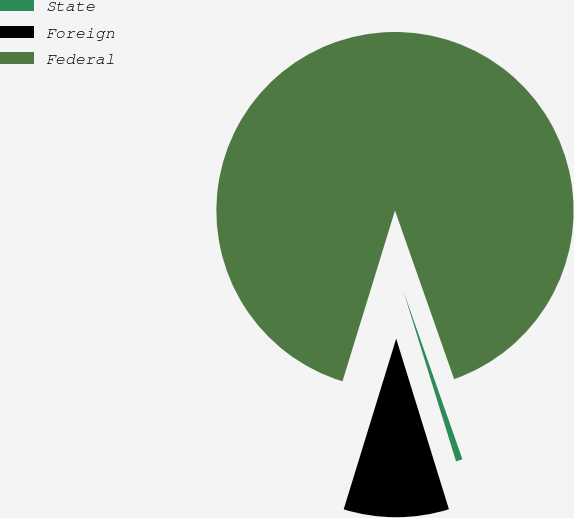<chart> <loc_0><loc_0><loc_500><loc_500><pie_chart><fcel>State<fcel>Foreign<fcel>Federal<nl><fcel>0.6%<fcel>9.52%<fcel>89.88%<nl></chart> 